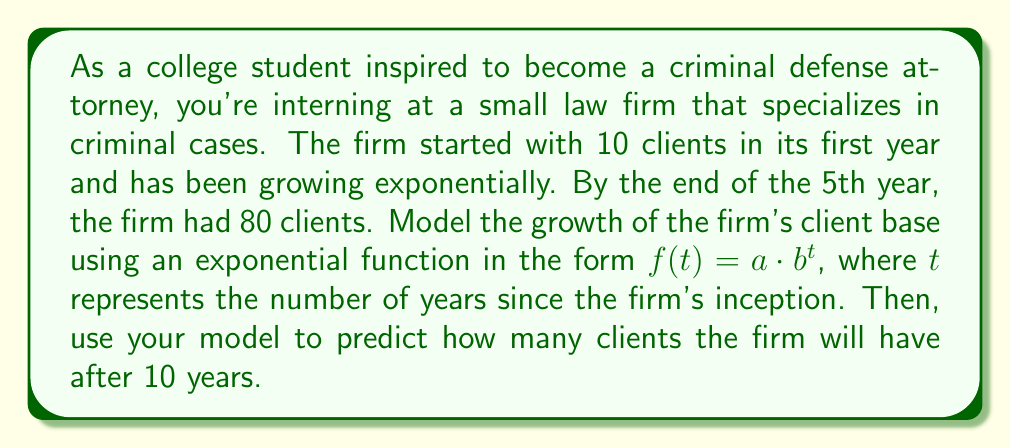Solve this math problem. Let's approach this step-by-step:

1) The exponential function has the form $f(t) = a \cdot b^t$, where:
   $a$ is the initial value (number of clients at $t=0$)
   $b$ is the growth factor
   $t$ is the time in years

2) We know that:
   At $t=0$, $f(0) = 10$ (initial clients)
   At $t=5$, $f(5) = 80$ (clients after 5 years)

3) Let's use these points to set up our equations:
   $f(0) = a \cdot b^0 = a = 10$
   $f(5) = 10 \cdot b^5 = 80$

4) From the second equation:
   $10 \cdot b^5 = 80$
   $b^5 = 8$
   $b = \sqrt[5]{8} \approx 1.5157$

5) So our function is:
   $f(t) = 10 \cdot (1.5157)^t$

6) To find the number of clients after 10 years, we calculate $f(10)$:
   $f(10) = 10 \cdot (1.5157)^{10} \approx 242.87$

7) Since we can't have a fractional number of clients, we round to the nearest whole number.
Answer: The exponential function modeling the firm's growth is $f(t) = 10 \cdot (1.5157)^t$, where $t$ is the number of years since the firm's inception. After 10 years, the firm is predicted to have approximately 243 clients. 